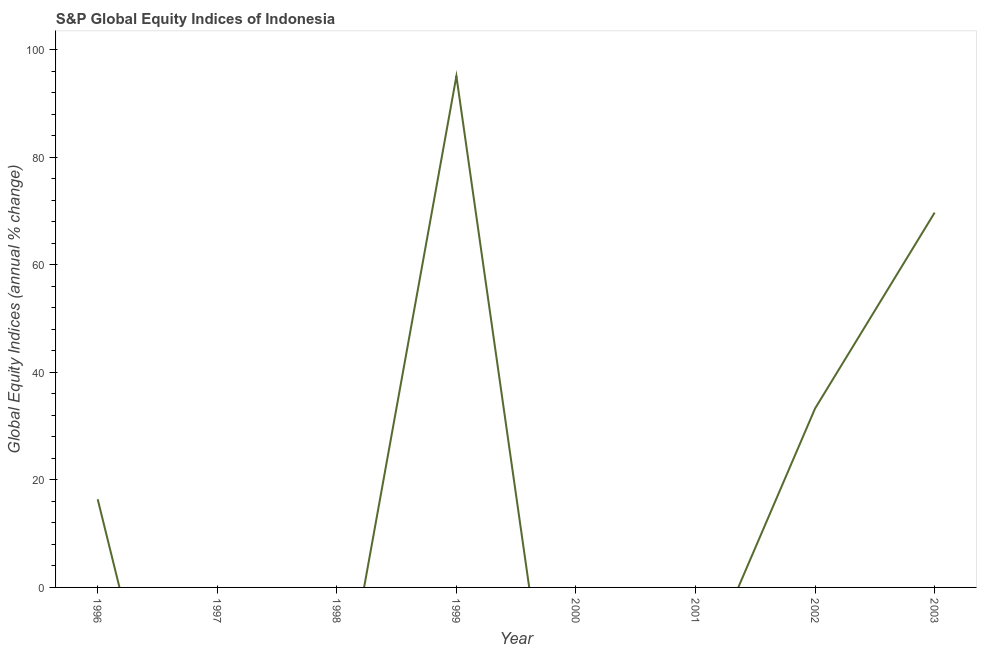What is the s&p global equity indices in 1997?
Provide a succinct answer. 0. Across all years, what is the maximum s&p global equity indices?
Your answer should be compact. 95.1. Across all years, what is the minimum s&p global equity indices?
Provide a short and direct response. 0. In which year was the s&p global equity indices maximum?
Give a very brief answer. 1999. What is the sum of the s&p global equity indices?
Make the answer very short. 214.51. What is the difference between the s&p global equity indices in 1999 and 2002?
Provide a short and direct response. 61.81. What is the average s&p global equity indices per year?
Keep it short and to the point. 26.81. What is the median s&p global equity indices?
Your answer should be compact. 8.2. What is the ratio of the s&p global equity indices in 1999 to that in 2002?
Provide a succinct answer. 2.86. What is the difference between the highest and the second highest s&p global equity indices?
Give a very brief answer. 25.38. What is the difference between the highest and the lowest s&p global equity indices?
Make the answer very short. 95.1. In how many years, is the s&p global equity indices greater than the average s&p global equity indices taken over all years?
Your response must be concise. 3. Does the s&p global equity indices monotonically increase over the years?
Provide a short and direct response. No. How many lines are there?
Your answer should be compact. 1. What is the difference between two consecutive major ticks on the Y-axis?
Your response must be concise. 20. Are the values on the major ticks of Y-axis written in scientific E-notation?
Keep it short and to the point. No. Does the graph contain any zero values?
Provide a succinct answer. Yes. Does the graph contain grids?
Provide a short and direct response. No. What is the title of the graph?
Your answer should be compact. S&P Global Equity Indices of Indonesia. What is the label or title of the X-axis?
Provide a succinct answer. Year. What is the label or title of the Y-axis?
Your response must be concise. Global Equity Indices (annual % change). What is the Global Equity Indices (annual % change) of 1996?
Make the answer very short. 16.4. What is the Global Equity Indices (annual % change) of 1997?
Your response must be concise. 0. What is the Global Equity Indices (annual % change) of 1998?
Your answer should be compact. 0. What is the Global Equity Indices (annual % change) in 1999?
Ensure brevity in your answer.  95.1. What is the Global Equity Indices (annual % change) in 2001?
Offer a very short reply. 0. What is the Global Equity Indices (annual % change) in 2002?
Give a very brief answer. 33.29. What is the Global Equity Indices (annual % change) of 2003?
Offer a terse response. 69.72. What is the difference between the Global Equity Indices (annual % change) in 1996 and 1999?
Your answer should be very brief. -78.7. What is the difference between the Global Equity Indices (annual % change) in 1996 and 2002?
Your answer should be compact. -16.89. What is the difference between the Global Equity Indices (annual % change) in 1996 and 2003?
Provide a succinct answer. -53.32. What is the difference between the Global Equity Indices (annual % change) in 1999 and 2002?
Provide a succinct answer. 61.81. What is the difference between the Global Equity Indices (annual % change) in 1999 and 2003?
Your response must be concise. 25.38. What is the difference between the Global Equity Indices (annual % change) in 2002 and 2003?
Give a very brief answer. -36.43. What is the ratio of the Global Equity Indices (annual % change) in 1996 to that in 1999?
Make the answer very short. 0.17. What is the ratio of the Global Equity Indices (annual % change) in 1996 to that in 2002?
Offer a very short reply. 0.49. What is the ratio of the Global Equity Indices (annual % change) in 1996 to that in 2003?
Your answer should be compact. 0.23. What is the ratio of the Global Equity Indices (annual % change) in 1999 to that in 2002?
Keep it short and to the point. 2.86. What is the ratio of the Global Equity Indices (annual % change) in 1999 to that in 2003?
Provide a short and direct response. 1.36. What is the ratio of the Global Equity Indices (annual % change) in 2002 to that in 2003?
Your answer should be very brief. 0.48. 